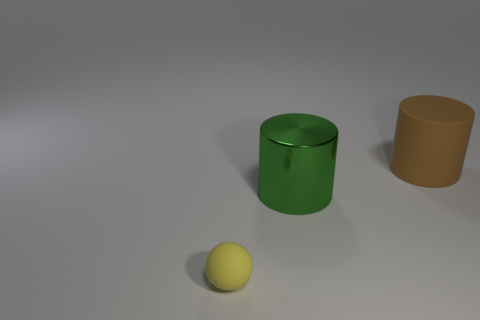There is another cylinder that is the same size as the green metallic cylinder; what is its color?
Keep it short and to the point. Brown. How many other objects are there of the same shape as the large brown matte object?
Provide a short and direct response. 1. Is there a yellow object that has the same material as the brown cylinder?
Make the answer very short. Yes. Is the material of the object to the left of the large green shiny cylinder the same as the large cylinder in front of the big brown cylinder?
Your answer should be very brief. No. What number of metal objects are there?
Offer a terse response. 1. There is a large object that is left of the large brown rubber thing; what shape is it?
Your answer should be very brief. Cylinder. What number of other things are there of the same size as the brown matte cylinder?
Your response must be concise. 1. Do the big thing that is in front of the big brown cylinder and the rubber object in front of the big brown object have the same shape?
Your answer should be very brief. No. There is a yellow thing; how many metallic cylinders are left of it?
Keep it short and to the point. 0. There is a matte object that is behind the big green cylinder; what color is it?
Ensure brevity in your answer.  Brown. 